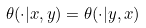Convert formula to latex. <formula><loc_0><loc_0><loc_500><loc_500>\theta ( \cdot | x , y ) = \theta ( \cdot | y , x )</formula> 